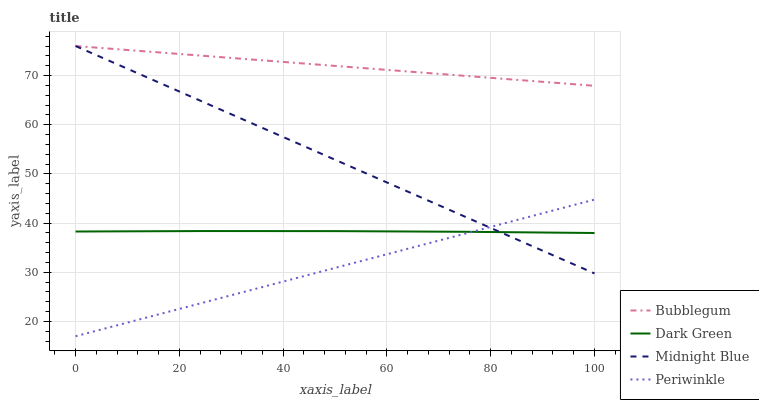Does Periwinkle have the minimum area under the curve?
Answer yes or no. Yes. Does Bubblegum have the maximum area under the curve?
Answer yes or no. Yes. Does Midnight Blue have the minimum area under the curve?
Answer yes or no. No. Does Midnight Blue have the maximum area under the curve?
Answer yes or no. No. Is Periwinkle the smoothest?
Answer yes or no. Yes. Is Dark Green the roughest?
Answer yes or no. Yes. Is Bubblegum the smoothest?
Answer yes or no. No. Is Bubblegum the roughest?
Answer yes or no. No. Does Midnight Blue have the lowest value?
Answer yes or no. No. Does Bubblegum have the highest value?
Answer yes or no. Yes. Does Dark Green have the highest value?
Answer yes or no. No. Is Dark Green less than Bubblegum?
Answer yes or no. Yes. Is Bubblegum greater than Dark Green?
Answer yes or no. Yes. Does Midnight Blue intersect Bubblegum?
Answer yes or no. Yes. Is Midnight Blue less than Bubblegum?
Answer yes or no. No. Is Midnight Blue greater than Bubblegum?
Answer yes or no. No. Does Dark Green intersect Bubblegum?
Answer yes or no. No. 